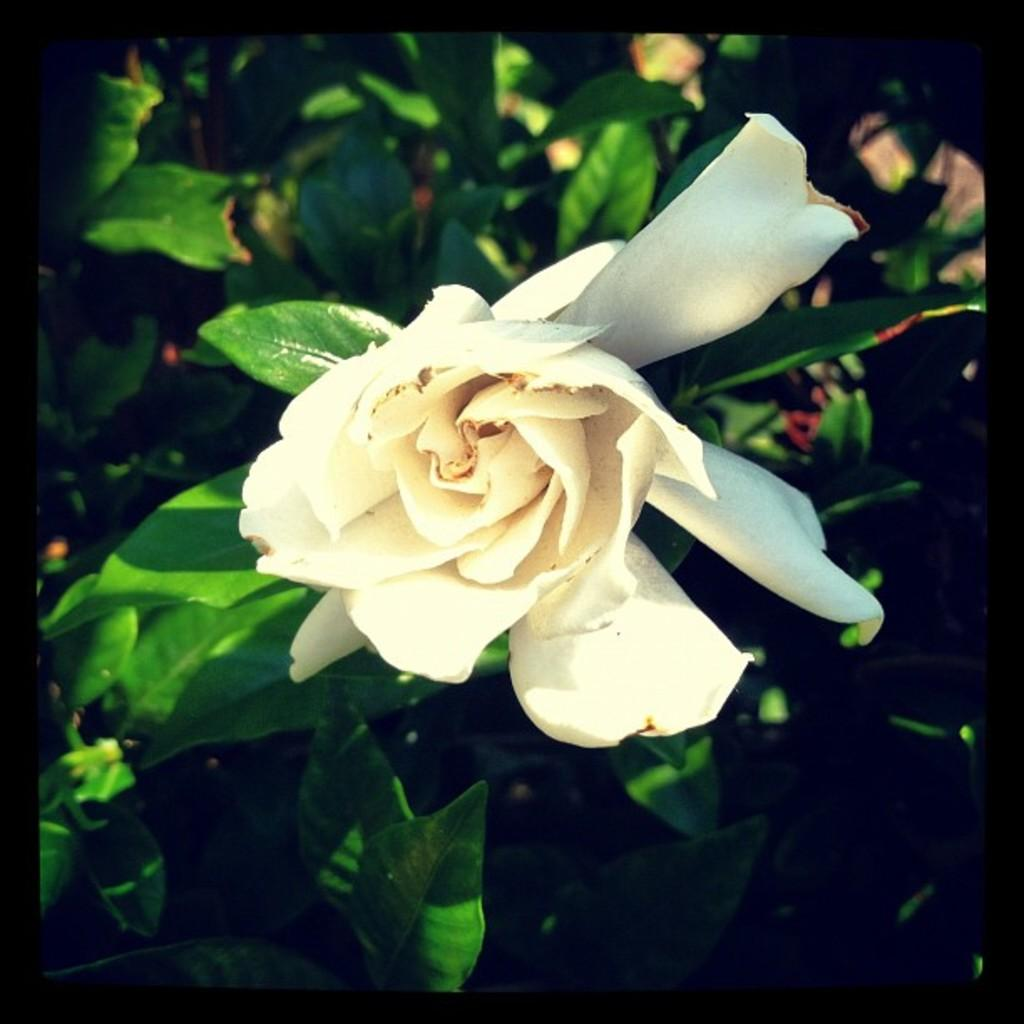What type of flower is present in the image? There is a white flower in the image. What can be seen in the background of the image? There are leaves visible in the background of the image. How does the flower contribute to the wealth of the person in the image? There is no person present in the image, and the flower's value or contribution to wealth cannot be determined from the image. 